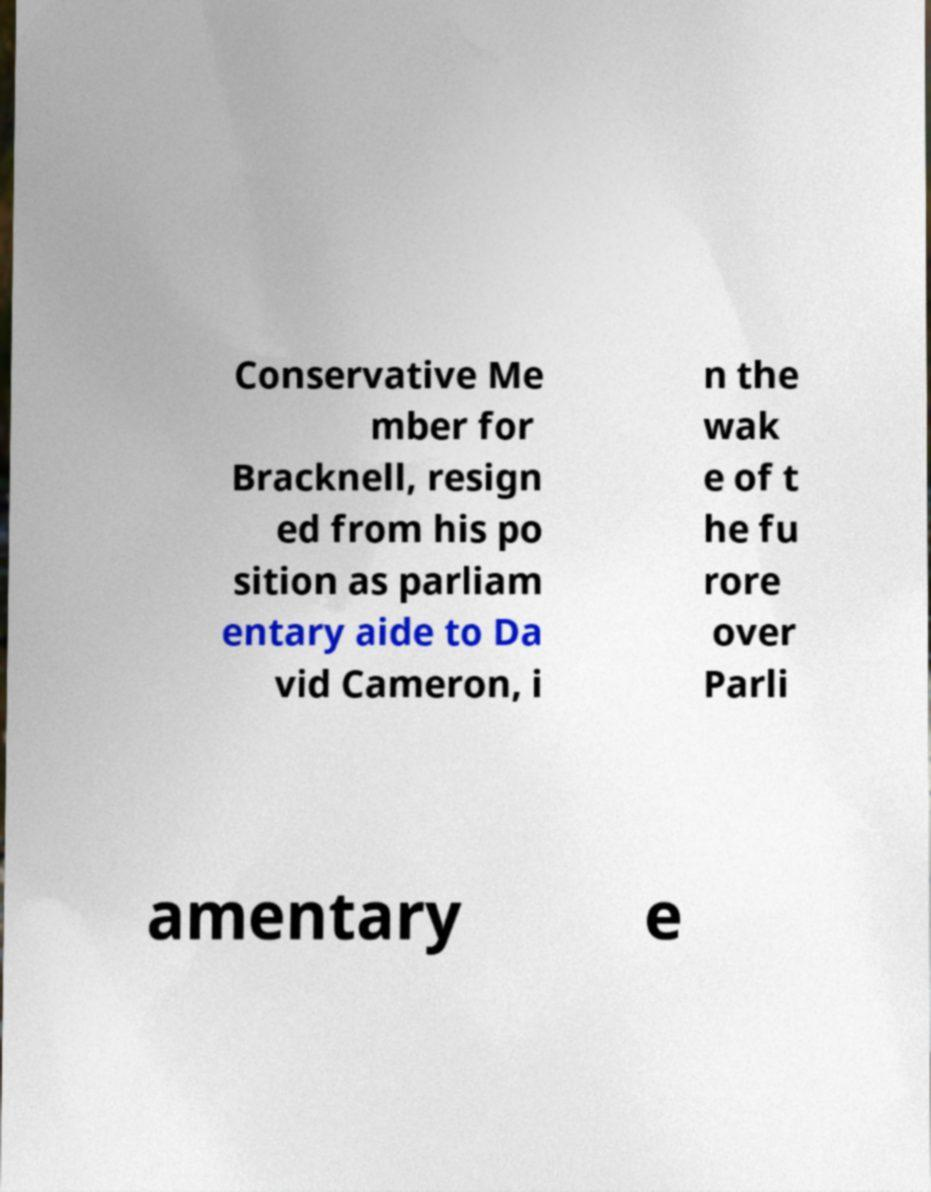Could you extract and type out the text from this image? Conservative Me mber for Bracknell, resign ed from his po sition as parliam entary aide to Da vid Cameron, i n the wak e of t he fu rore over Parli amentary e 